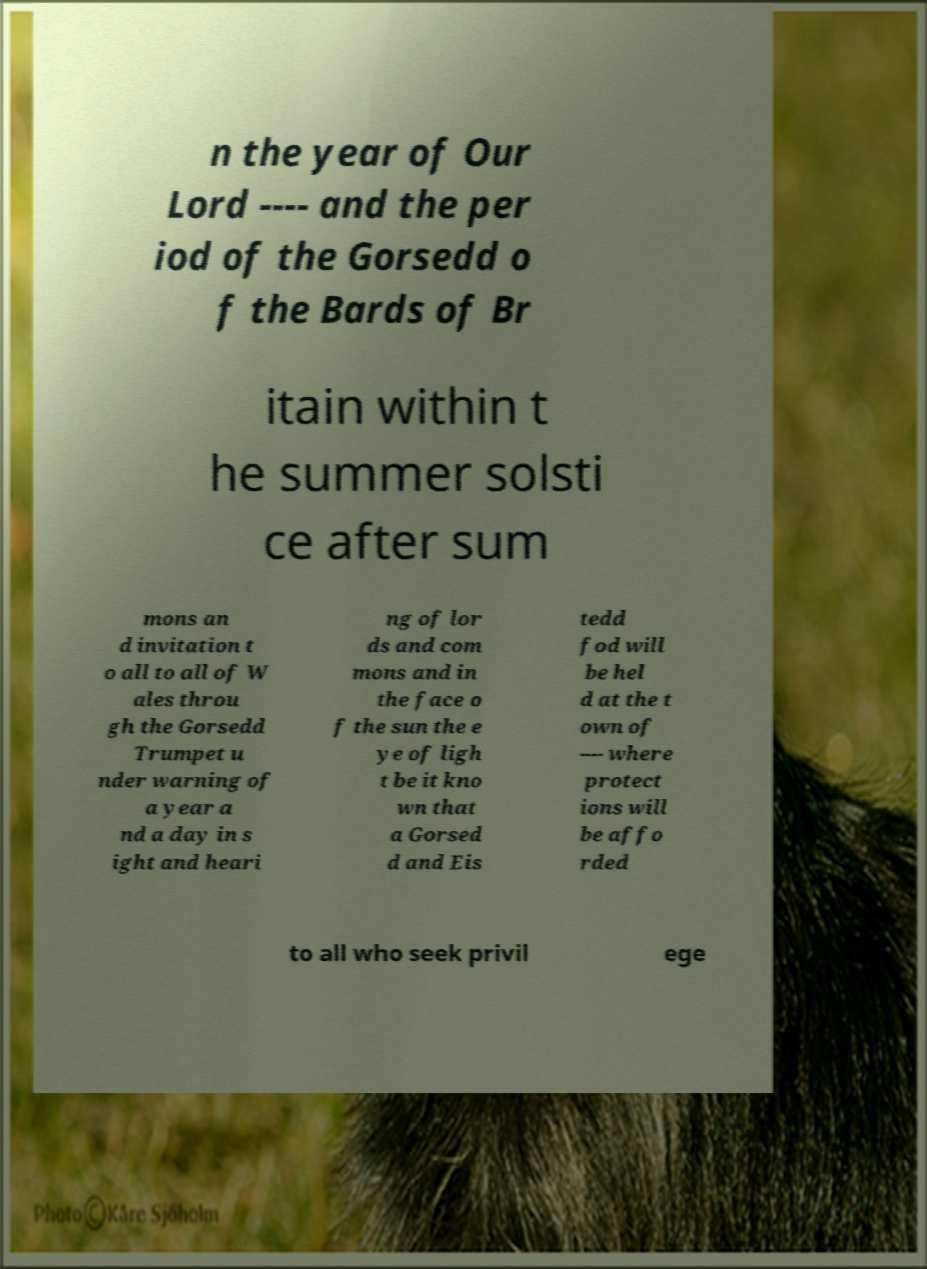I need the written content from this picture converted into text. Can you do that? n the year of Our Lord ---- and the per iod of the Gorsedd o f the Bards of Br itain within t he summer solsti ce after sum mons an d invitation t o all to all of W ales throu gh the Gorsedd Trumpet u nder warning of a year a nd a day in s ight and heari ng of lor ds and com mons and in the face o f the sun the e ye of ligh t be it kno wn that a Gorsed d and Eis tedd fod will be hel d at the t own of ---- where protect ions will be affo rded to all who seek privil ege 